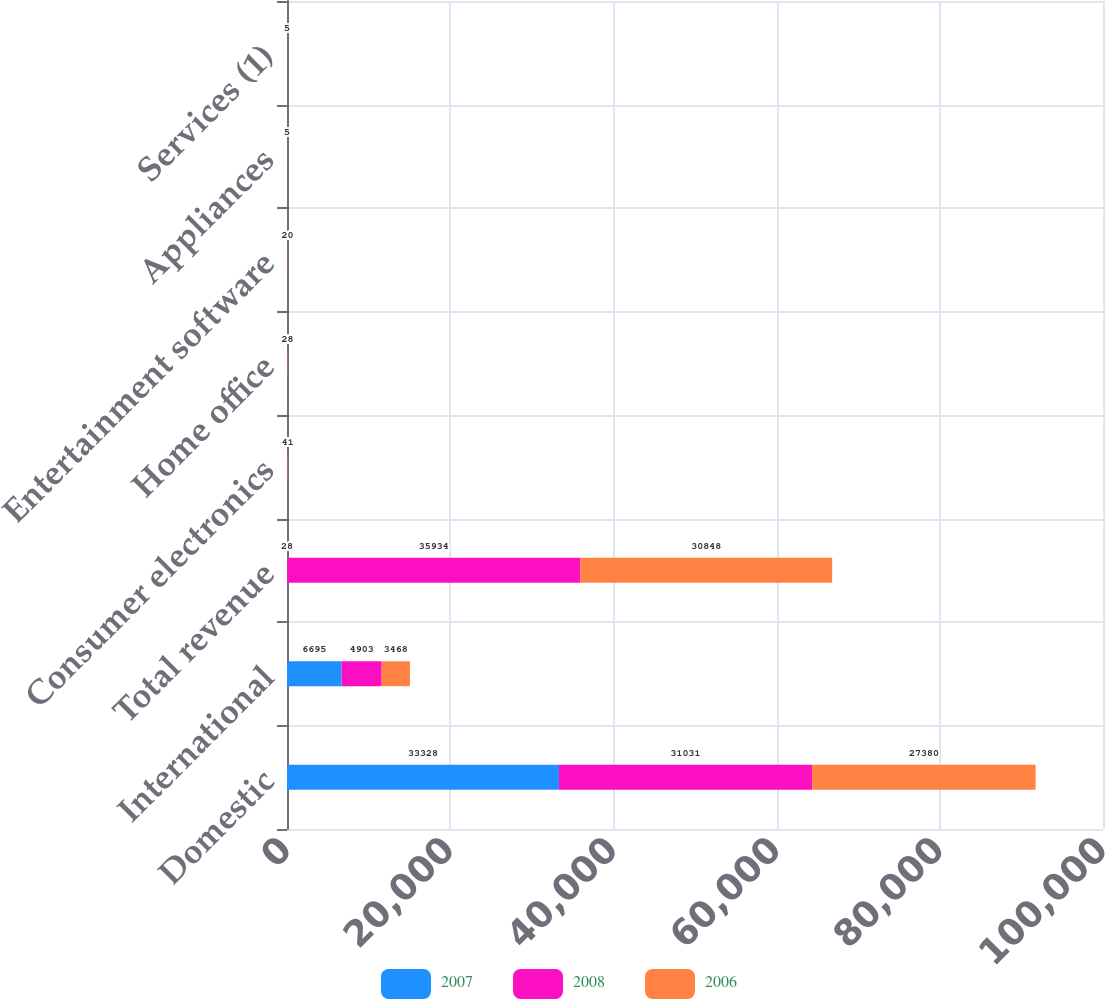Convert chart to OTSL. <chart><loc_0><loc_0><loc_500><loc_500><stacked_bar_chart><ecel><fcel>Domestic<fcel>International<fcel>Total revenue<fcel>Consumer electronics<fcel>Home office<fcel>Entertainment software<fcel>Appliances<fcel>Services (1)<nl><fcel>2007<fcel>33328<fcel>6695<fcel>28<fcel>41<fcel>28<fcel>20<fcel>5<fcel>6<nl><fcel>2008<fcel>31031<fcel>4903<fcel>35934<fcel>42<fcel>27<fcel>19<fcel>6<fcel>5<nl><fcel>2006<fcel>27380<fcel>3468<fcel>30848<fcel>41<fcel>28<fcel>20<fcel>5<fcel>5<nl></chart> 